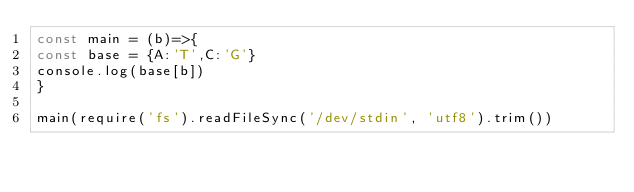<code> <loc_0><loc_0><loc_500><loc_500><_JavaScript_>const main = (b)=>{
const base = {A:'T',C:'G'}
console.log(base[b])
}

main(require('fs').readFileSync('/dev/stdin', 'utf8').trim())
</code> 